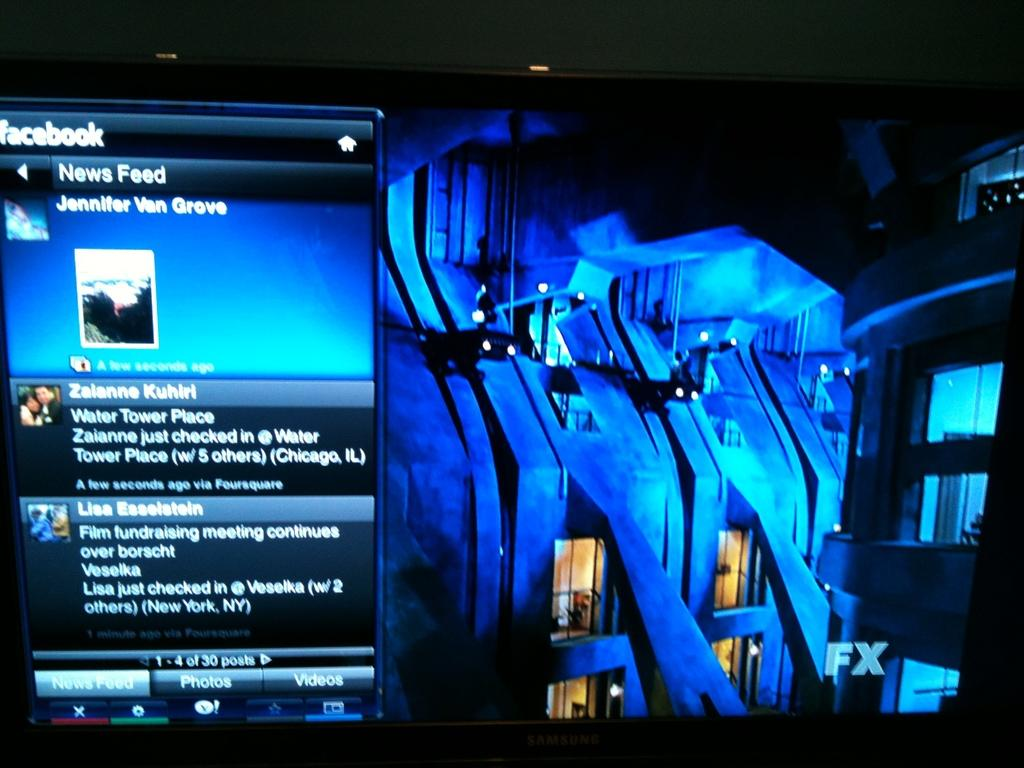<image>
Offer a succinct explanation of the picture presented. A monitor displays a Facebook menu with the heading of "News Feed." 